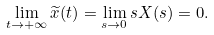<formula> <loc_0><loc_0><loc_500><loc_500>\lim _ { t \rightarrow + \infty } \widetilde { x } ( t ) = \lim _ { s \rightarrow 0 } s X ( s ) = 0 .</formula> 